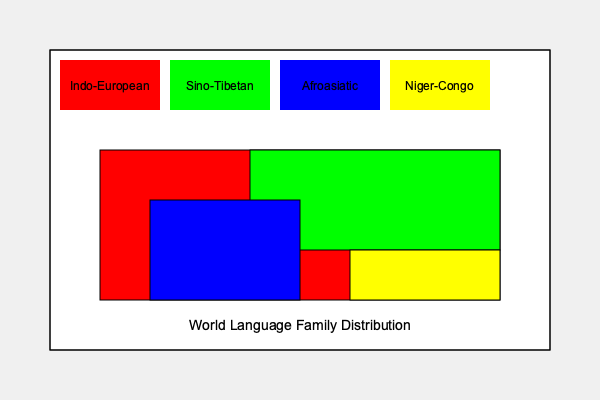Based on the color-coded map of world language family distribution, which language family appears to cover the largest geographical area? To determine which language family covers the largest geographical area, we need to analyze the color-coded map:

1. Identify the language families:
   - Red: Indo-European
   - Green: Sino-Tibetan
   - Blue: Afroasiatic
   - Yellow: Niger-Congo

2. Assess the geographical coverage:
   - Indo-European (red) covers most of Europe, parts of South Asia, and significant portions of the Americas.
   - Sino-Tibetan (green) covers East Asia, including China and surrounding regions.
   - Afroasiatic (blue) covers parts of North Africa and the Middle East.
   - Niger-Congo (yellow) covers a small portion of sub-Saharan Africa.

3. Compare the areas:
   - Indo-European clearly covers the largest area, spanning multiple continents.
   - Sino-Tibetan is the second largest, but primarily concentrated in East Asia.
   - Afroasiatic and Niger-Congo cover smaller, more localized areas.

4. Consider the map projection:
   - Even accounting for potential distortions in map projections, the Indo-European family still appears to cover the largest area.

5. Cultural adaptation relevance:
   - As an ESL teacher, understanding the widespread nature of Indo-European languages can help in explaining linguistic similarities and differences to students from various backgrounds.

Based on this analysis, the Indo-European language family covers the largest geographical area on the map.
Answer: Indo-European 